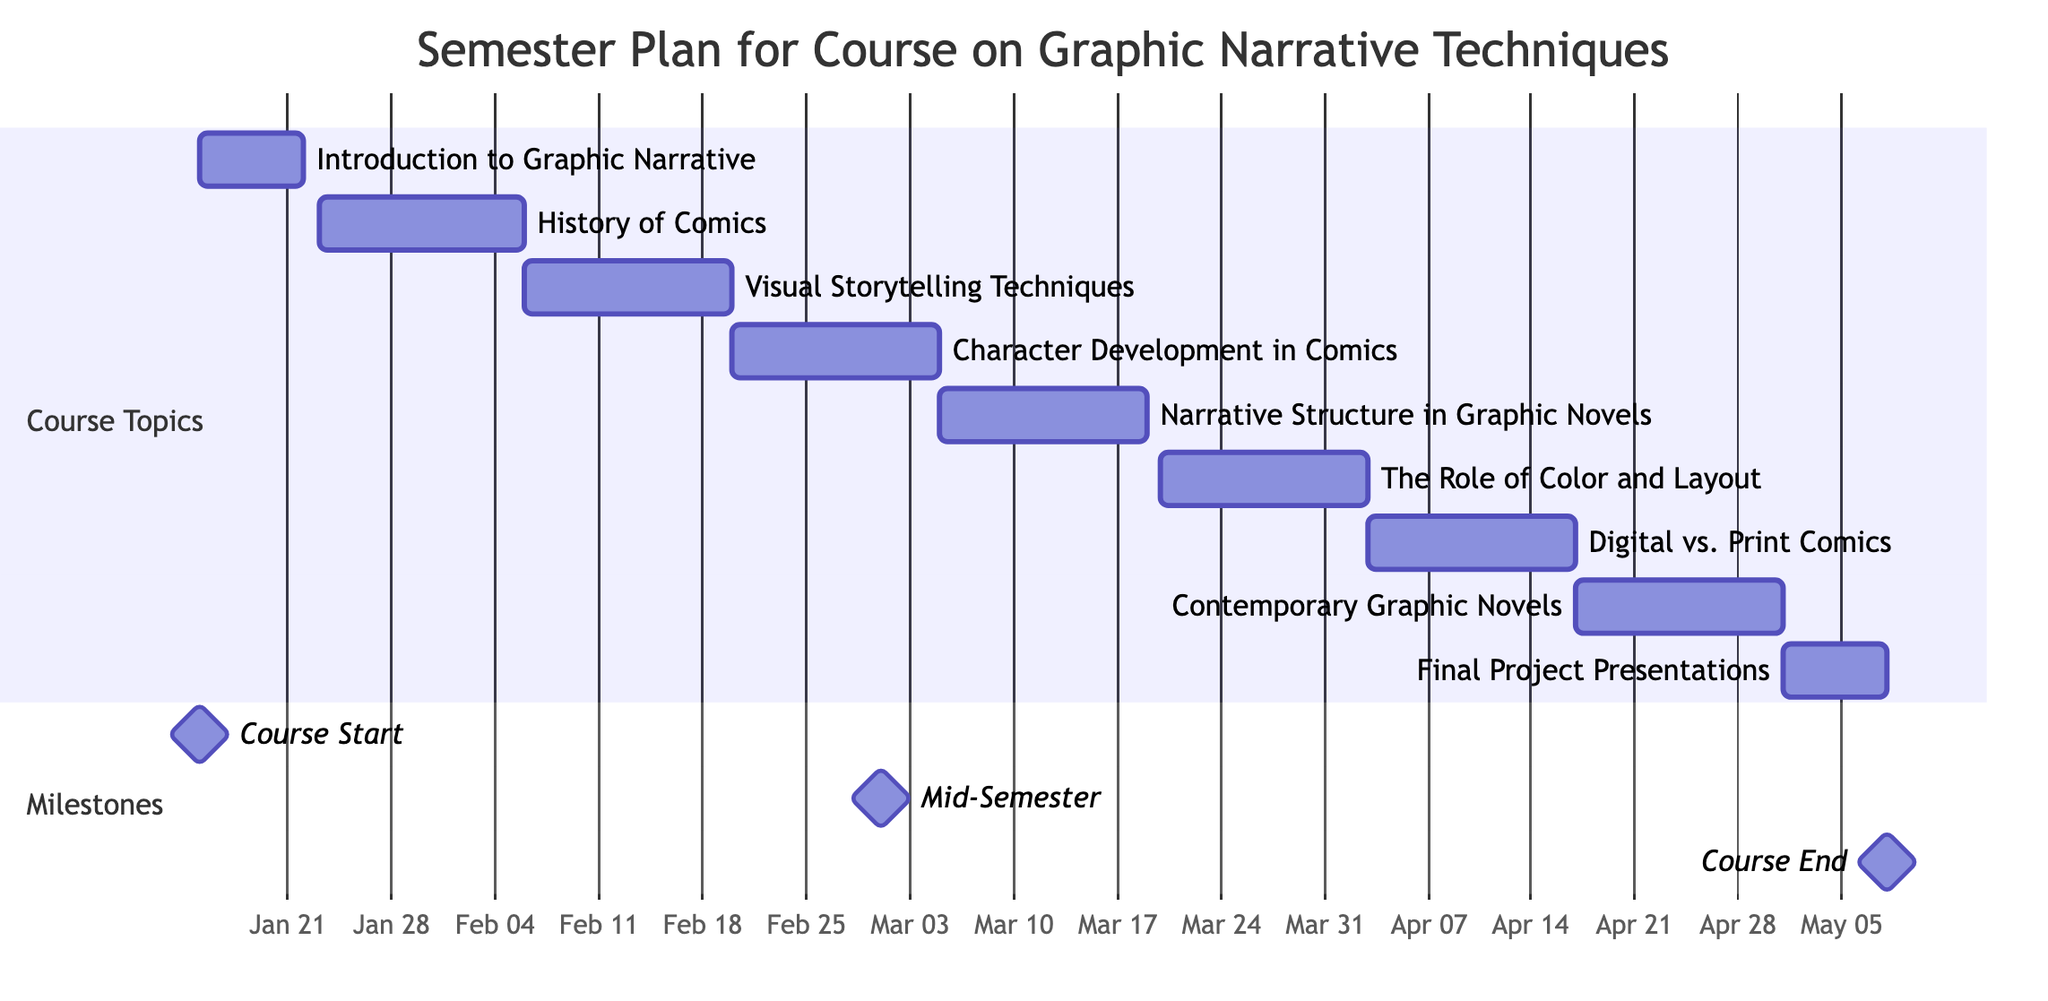What is the duration of the "Introduction to Graphic Narrative" task? The task starts on January 15, 2024, and ends on January 22, 2024. The duration is calculated by finding the difference between the end date and the start date, which is 1 week.
Answer: 1 week What is the end date for the "Narrative Structure in Graphic Novels" task? The task is scheduled to end on March 19, 2024. This information is directly available within the task's details on the diagram.
Answer: March 19, 2024 How many tasks take place in February 2024? The diagram indicates three tasks: "Visual Storytelling Techniques," "Character Development in Comics," and "The Role of Color and Layout," which are all scheduled in February 2024.
Answer: 3 What task follows "The Role of Color and Layout"? The task subsequent to "The Role of Color and Layout" is "Digital vs. Print Comics." This is determined by looking at the sequential order of tasks in the diagram.
Answer: Digital vs. Print Comics How many total weeks is the course planned for? The course comprises eight tasks, with durations of 1 week or 2 weeks each. Adding these durations gives a total of 15 weeks, hence the course spans from January 15 to May 8, 2024.
Answer: 15 weeks Which task overlaps with the mid-semester milestone? The mid-semester milestone is on March 1, 2024, which falls within the duration of "Character Development in Comics" (February 20 - March 4) and "Narrative Structure in Graphic Novels" (March 5 - March 19). Therefore, "Character Development in Comics" overlaps with the milestone.
Answer: Character Development in Comics What is the final project presentation duration? The final project presentations are scheduled from May 1, 2024, to May 8, 2024, equating to a duration of 1 week. This information is explicitly mentioned in the task details.
Answer: 1 week Which task starts immediately after "History of Comics"? The task that begins immediately after "History of Comics" (which ends on February 5, 2024) is "Visual Storytelling Techniques," starting on February 6, 2024, as it follows directly in the timeline.
Answer: Visual Storytelling Techniques 